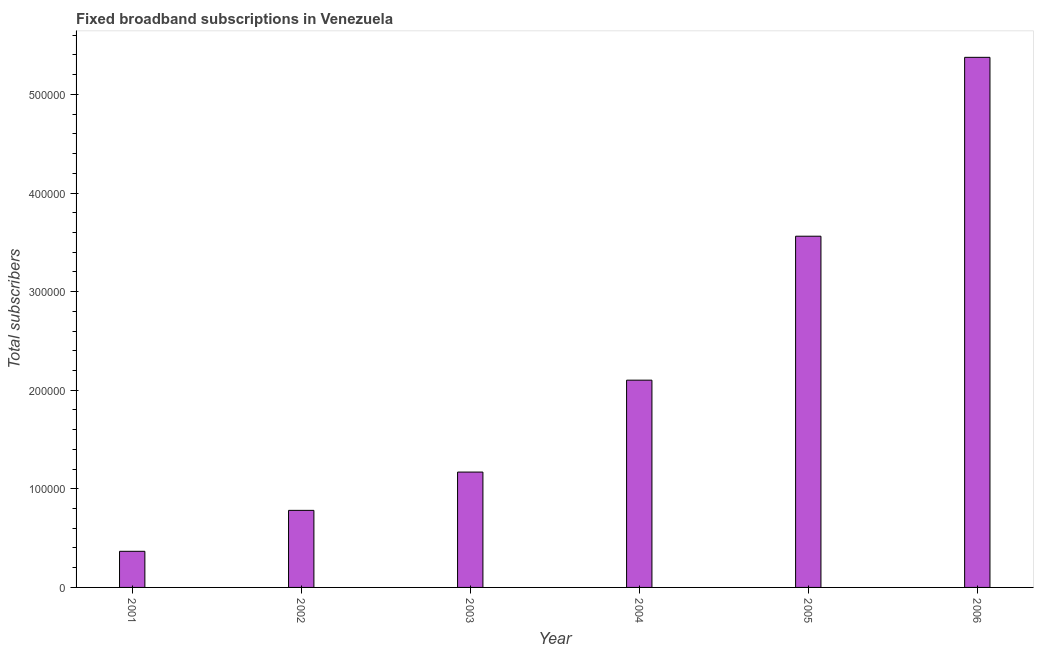Does the graph contain any zero values?
Keep it short and to the point. No. Does the graph contain grids?
Offer a terse response. No. What is the title of the graph?
Give a very brief answer. Fixed broadband subscriptions in Venezuela. What is the label or title of the X-axis?
Provide a short and direct response. Year. What is the label or title of the Y-axis?
Your response must be concise. Total subscribers. What is the total number of fixed broadband subscriptions in 2003?
Offer a terse response. 1.17e+05. Across all years, what is the maximum total number of fixed broadband subscriptions?
Provide a succinct answer. 5.38e+05. Across all years, what is the minimum total number of fixed broadband subscriptions?
Provide a short and direct response. 3.66e+04. In which year was the total number of fixed broadband subscriptions minimum?
Your answer should be very brief. 2001. What is the sum of the total number of fixed broadband subscriptions?
Offer a very short reply. 1.34e+06. What is the difference between the total number of fixed broadband subscriptions in 2001 and 2003?
Offer a terse response. -8.04e+04. What is the average total number of fixed broadband subscriptions per year?
Provide a succinct answer. 2.23e+05. What is the median total number of fixed broadband subscriptions?
Give a very brief answer. 1.64e+05. In how many years, is the total number of fixed broadband subscriptions greater than 300000 ?
Provide a succinct answer. 2. Do a majority of the years between 2003 and 2006 (inclusive) have total number of fixed broadband subscriptions greater than 320000 ?
Your response must be concise. No. What is the ratio of the total number of fixed broadband subscriptions in 2001 to that in 2004?
Your answer should be compact. 0.17. What is the difference between the highest and the second highest total number of fixed broadband subscriptions?
Offer a terse response. 1.81e+05. What is the difference between the highest and the lowest total number of fixed broadband subscriptions?
Offer a terse response. 5.01e+05. How many bars are there?
Make the answer very short. 6. Are all the bars in the graph horizontal?
Make the answer very short. No. How many years are there in the graph?
Offer a very short reply. 6. Are the values on the major ticks of Y-axis written in scientific E-notation?
Provide a succinct answer. No. What is the Total subscribers in 2001?
Your response must be concise. 3.66e+04. What is the Total subscribers of 2002?
Provide a succinct answer. 7.82e+04. What is the Total subscribers in 2003?
Provide a succinct answer. 1.17e+05. What is the Total subscribers in 2004?
Give a very brief answer. 2.10e+05. What is the Total subscribers of 2005?
Give a very brief answer. 3.56e+05. What is the Total subscribers in 2006?
Provide a short and direct response. 5.38e+05. What is the difference between the Total subscribers in 2001 and 2002?
Your response must be concise. -4.15e+04. What is the difference between the Total subscribers in 2001 and 2003?
Give a very brief answer. -8.04e+04. What is the difference between the Total subscribers in 2001 and 2004?
Ensure brevity in your answer.  -1.74e+05. What is the difference between the Total subscribers in 2001 and 2005?
Keep it short and to the point. -3.20e+05. What is the difference between the Total subscribers in 2001 and 2006?
Your answer should be very brief. -5.01e+05. What is the difference between the Total subscribers in 2002 and 2003?
Ensure brevity in your answer.  -3.88e+04. What is the difference between the Total subscribers in 2002 and 2004?
Offer a terse response. -1.32e+05. What is the difference between the Total subscribers in 2002 and 2005?
Ensure brevity in your answer.  -2.78e+05. What is the difference between the Total subscribers in 2002 and 2006?
Your response must be concise. -4.59e+05. What is the difference between the Total subscribers in 2003 and 2004?
Give a very brief answer. -9.32e+04. What is the difference between the Total subscribers in 2003 and 2005?
Offer a terse response. -2.39e+05. What is the difference between the Total subscribers in 2003 and 2006?
Your answer should be very brief. -4.21e+05. What is the difference between the Total subscribers in 2004 and 2005?
Offer a very short reply. -1.46e+05. What is the difference between the Total subscribers in 2004 and 2006?
Offer a terse response. -3.27e+05. What is the difference between the Total subscribers in 2005 and 2006?
Ensure brevity in your answer.  -1.81e+05. What is the ratio of the Total subscribers in 2001 to that in 2002?
Provide a succinct answer. 0.47. What is the ratio of the Total subscribers in 2001 to that in 2003?
Provide a succinct answer. 0.31. What is the ratio of the Total subscribers in 2001 to that in 2004?
Offer a very short reply. 0.17. What is the ratio of the Total subscribers in 2001 to that in 2005?
Make the answer very short. 0.1. What is the ratio of the Total subscribers in 2001 to that in 2006?
Provide a short and direct response. 0.07. What is the ratio of the Total subscribers in 2002 to that in 2003?
Offer a very short reply. 0.67. What is the ratio of the Total subscribers in 2002 to that in 2004?
Provide a short and direct response. 0.37. What is the ratio of the Total subscribers in 2002 to that in 2005?
Give a very brief answer. 0.22. What is the ratio of the Total subscribers in 2002 to that in 2006?
Provide a short and direct response. 0.14. What is the ratio of the Total subscribers in 2003 to that in 2004?
Your answer should be compact. 0.56. What is the ratio of the Total subscribers in 2003 to that in 2005?
Make the answer very short. 0.33. What is the ratio of the Total subscribers in 2003 to that in 2006?
Offer a very short reply. 0.22. What is the ratio of the Total subscribers in 2004 to that in 2005?
Ensure brevity in your answer.  0.59. What is the ratio of the Total subscribers in 2004 to that in 2006?
Give a very brief answer. 0.39. What is the ratio of the Total subscribers in 2005 to that in 2006?
Offer a terse response. 0.66. 